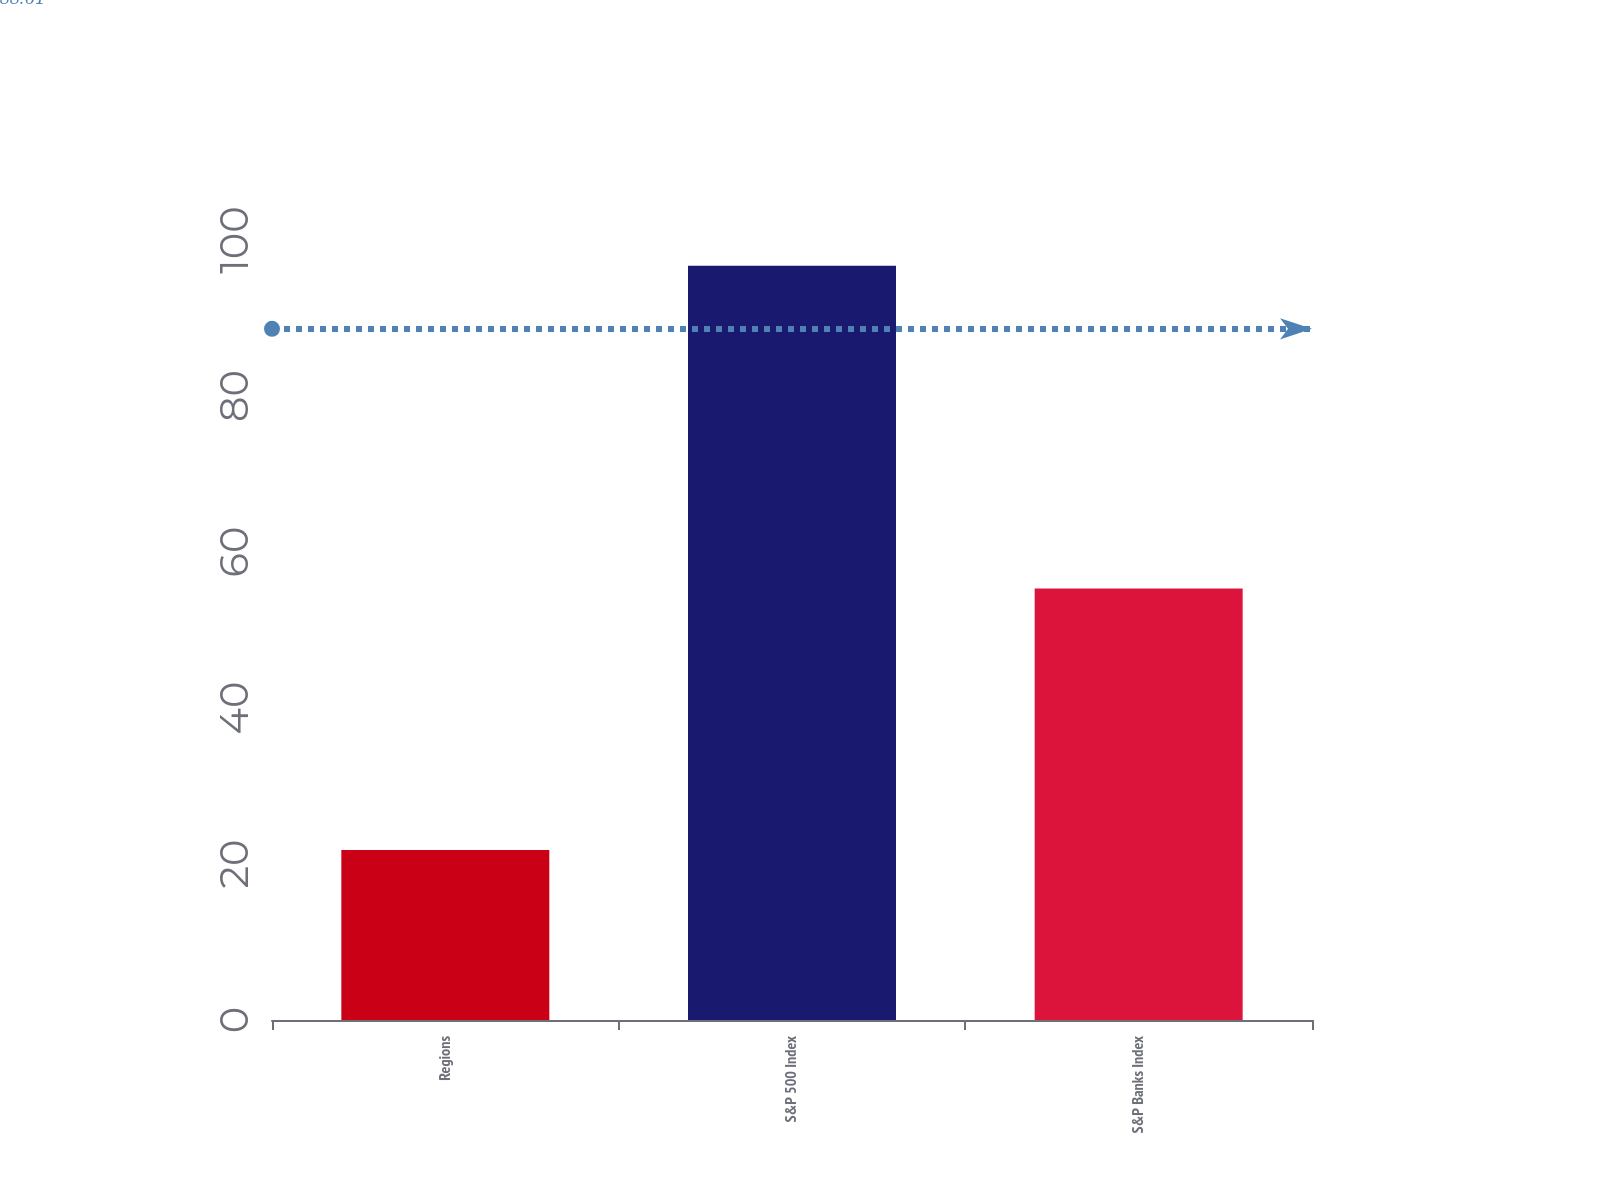Convert chart. <chart><loc_0><loc_0><loc_500><loc_500><bar_chart><fcel>Regions<fcel>S&P 500 Index<fcel>S&P Banks Index<nl><fcel>21.81<fcel>96.71<fcel>55.31<nl></chart> 